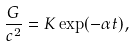<formula> <loc_0><loc_0><loc_500><loc_500>\frac { G } { c ^ { 2 } } = K \exp ( - \alpha t ) ,</formula> 